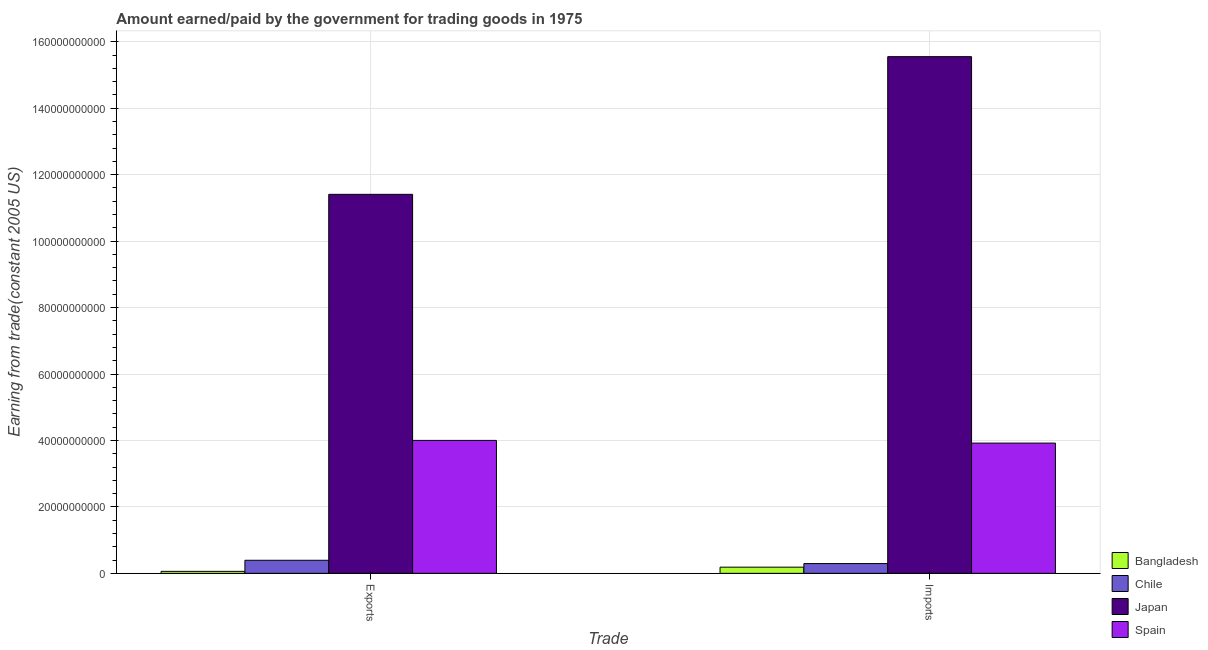How many different coloured bars are there?
Offer a very short reply. 4. How many groups of bars are there?
Provide a succinct answer. 2. Are the number of bars on each tick of the X-axis equal?
Offer a terse response. Yes. What is the label of the 2nd group of bars from the left?
Your answer should be very brief. Imports. What is the amount earned from exports in Spain?
Offer a very short reply. 4.00e+1. Across all countries, what is the maximum amount paid for imports?
Offer a very short reply. 1.56e+11. Across all countries, what is the minimum amount paid for imports?
Your answer should be compact. 1.86e+09. In which country was the amount paid for imports minimum?
Provide a short and direct response. Bangladesh. What is the total amount earned from exports in the graph?
Your answer should be compact. 1.59e+11. What is the difference between the amount paid for imports in Japan and that in Bangladesh?
Keep it short and to the point. 1.54e+11. What is the difference between the amount earned from exports in Bangladesh and the amount paid for imports in Spain?
Give a very brief answer. -3.86e+1. What is the average amount earned from exports per country?
Offer a very short reply. 3.97e+1. What is the difference between the amount paid for imports and amount earned from exports in Chile?
Provide a short and direct response. -9.94e+08. What is the ratio of the amount earned from exports in Spain to that in Chile?
Keep it short and to the point. 10.18. Is the amount earned from exports in Chile less than that in Japan?
Your answer should be compact. Yes. How many bars are there?
Your answer should be compact. 8. Are all the bars in the graph horizontal?
Your answer should be compact. No. What is the difference between two consecutive major ticks on the Y-axis?
Your answer should be compact. 2.00e+1. Are the values on the major ticks of Y-axis written in scientific E-notation?
Your answer should be very brief. No. Does the graph contain any zero values?
Your answer should be compact. No. What is the title of the graph?
Your answer should be very brief. Amount earned/paid by the government for trading goods in 1975. Does "Greenland" appear as one of the legend labels in the graph?
Your answer should be compact. No. What is the label or title of the X-axis?
Provide a succinct answer. Trade. What is the label or title of the Y-axis?
Your answer should be compact. Earning from trade(constant 2005 US). What is the Earning from trade(constant 2005 US) in Bangladesh in Exports?
Give a very brief answer. 5.97e+08. What is the Earning from trade(constant 2005 US) in Chile in Exports?
Keep it short and to the point. 3.93e+09. What is the Earning from trade(constant 2005 US) in Japan in Exports?
Your answer should be very brief. 1.14e+11. What is the Earning from trade(constant 2005 US) in Spain in Exports?
Make the answer very short. 4.00e+1. What is the Earning from trade(constant 2005 US) of Bangladesh in Imports?
Ensure brevity in your answer.  1.86e+09. What is the Earning from trade(constant 2005 US) of Chile in Imports?
Provide a succinct answer. 2.94e+09. What is the Earning from trade(constant 2005 US) of Japan in Imports?
Provide a short and direct response. 1.56e+11. What is the Earning from trade(constant 2005 US) in Spain in Imports?
Your answer should be compact. 3.92e+1. Across all Trade, what is the maximum Earning from trade(constant 2005 US) of Bangladesh?
Keep it short and to the point. 1.86e+09. Across all Trade, what is the maximum Earning from trade(constant 2005 US) of Chile?
Ensure brevity in your answer.  3.93e+09. Across all Trade, what is the maximum Earning from trade(constant 2005 US) in Japan?
Your answer should be very brief. 1.56e+11. Across all Trade, what is the maximum Earning from trade(constant 2005 US) of Spain?
Provide a short and direct response. 4.00e+1. Across all Trade, what is the minimum Earning from trade(constant 2005 US) in Bangladesh?
Your answer should be compact. 5.97e+08. Across all Trade, what is the minimum Earning from trade(constant 2005 US) of Chile?
Provide a short and direct response. 2.94e+09. Across all Trade, what is the minimum Earning from trade(constant 2005 US) of Japan?
Offer a terse response. 1.14e+11. Across all Trade, what is the minimum Earning from trade(constant 2005 US) in Spain?
Make the answer very short. 3.92e+1. What is the total Earning from trade(constant 2005 US) of Bangladesh in the graph?
Keep it short and to the point. 2.45e+09. What is the total Earning from trade(constant 2005 US) in Chile in the graph?
Give a very brief answer. 6.87e+09. What is the total Earning from trade(constant 2005 US) of Japan in the graph?
Provide a succinct answer. 2.70e+11. What is the total Earning from trade(constant 2005 US) in Spain in the graph?
Your response must be concise. 7.92e+1. What is the difference between the Earning from trade(constant 2005 US) of Bangladesh in Exports and that in Imports?
Ensure brevity in your answer.  -1.26e+09. What is the difference between the Earning from trade(constant 2005 US) in Chile in Exports and that in Imports?
Give a very brief answer. 9.94e+08. What is the difference between the Earning from trade(constant 2005 US) of Japan in Exports and that in Imports?
Offer a very short reply. -4.14e+1. What is the difference between the Earning from trade(constant 2005 US) of Spain in Exports and that in Imports?
Provide a succinct answer. 8.10e+08. What is the difference between the Earning from trade(constant 2005 US) of Bangladesh in Exports and the Earning from trade(constant 2005 US) of Chile in Imports?
Offer a terse response. -2.34e+09. What is the difference between the Earning from trade(constant 2005 US) of Bangladesh in Exports and the Earning from trade(constant 2005 US) of Japan in Imports?
Make the answer very short. -1.55e+11. What is the difference between the Earning from trade(constant 2005 US) in Bangladesh in Exports and the Earning from trade(constant 2005 US) in Spain in Imports?
Provide a short and direct response. -3.86e+1. What is the difference between the Earning from trade(constant 2005 US) of Chile in Exports and the Earning from trade(constant 2005 US) of Japan in Imports?
Give a very brief answer. -1.52e+11. What is the difference between the Earning from trade(constant 2005 US) of Chile in Exports and the Earning from trade(constant 2005 US) of Spain in Imports?
Provide a short and direct response. -3.53e+1. What is the difference between the Earning from trade(constant 2005 US) of Japan in Exports and the Earning from trade(constant 2005 US) of Spain in Imports?
Keep it short and to the point. 7.49e+1. What is the average Earning from trade(constant 2005 US) in Bangladesh per Trade?
Your answer should be very brief. 1.23e+09. What is the average Earning from trade(constant 2005 US) of Chile per Trade?
Your response must be concise. 3.44e+09. What is the average Earning from trade(constant 2005 US) in Japan per Trade?
Your answer should be very brief. 1.35e+11. What is the average Earning from trade(constant 2005 US) in Spain per Trade?
Offer a terse response. 3.96e+1. What is the difference between the Earning from trade(constant 2005 US) in Bangladesh and Earning from trade(constant 2005 US) in Chile in Exports?
Provide a succinct answer. -3.34e+09. What is the difference between the Earning from trade(constant 2005 US) in Bangladesh and Earning from trade(constant 2005 US) in Japan in Exports?
Offer a terse response. -1.13e+11. What is the difference between the Earning from trade(constant 2005 US) of Bangladesh and Earning from trade(constant 2005 US) of Spain in Exports?
Offer a very short reply. -3.94e+1. What is the difference between the Earning from trade(constant 2005 US) of Chile and Earning from trade(constant 2005 US) of Japan in Exports?
Provide a short and direct response. -1.10e+11. What is the difference between the Earning from trade(constant 2005 US) in Chile and Earning from trade(constant 2005 US) in Spain in Exports?
Make the answer very short. -3.61e+1. What is the difference between the Earning from trade(constant 2005 US) in Japan and Earning from trade(constant 2005 US) in Spain in Exports?
Offer a terse response. 7.41e+1. What is the difference between the Earning from trade(constant 2005 US) of Bangladesh and Earning from trade(constant 2005 US) of Chile in Imports?
Offer a terse response. -1.08e+09. What is the difference between the Earning from trade(constant 2005 US) in Bangladesh and Earning from trade(constant 2005 US) in Japan in Imports?
Your answer should be very brief. -1.54e+11. What is the difference between the Earning from trade(constant 2005 US) in Bangladesh and Earning from trade(constant 2005 US) in Spain in Imports?
Your answer should be compact. -3.73e+1. What is the difference between the Earning from trade(constant 2005 US) in Chile and Earning from trade(constant 2005 US) in Japan in Imports?
Your response must be concise. -1.53e+11. What is the difference between the Earning from trade(constant 2005 US) of Chile and Earning from trade(constant 2005 US) of Spain in Imports?
Your answer should be very brief. -3.63e+1. What is the difference between the Earning from trade(constant 2005 US) in Japan and Earning from trade(constant 2005 US) in Spain in Imports?
Your answer should be very brief. 1.16e+11. What is the ratio of the Earning from trade(constant 2005 US) in Bangladesh in Exports to that in Imports?
Your response must be concise. 0.32. What is the ratio of the Earning from trade(constant 2005 US) in Chile in Exports to that in Imports?
Give a very brief answer. 1.34. What is the ratio of the Earning from trade(constant 2005 US) in Japan in Exports to that in Imports?
Provide a succinct answer. 0.73. What is the ratio of the Earning from trade(constant 2005 US) of Spain in Exports to that in Imports?
Ensure brevity in your answer.  1.02. What is the difference between the highest and the second highest Earning from trade(constant 2005 US) in Bangladesh?
Your response must be concise. 1.26e+09. What is the difference between the highest and the second highest Earning from trade(constant 2005 US) of Chile?
Your response must be concise. 9.94e+08. What is the difference between the highest and the second highest Earning from trade(constant 2005 US) in Japan?
Offer a terse response. 4.14e+1. What is the difference between the highest and the second highest Earning from trade(constant 2005 US) in Spain?
Your answer should be compact. 8.10e+08. What is the difference between the highest and the lowest Earning from trade(constant 2005 US) of Bangladesh?
Give a very brief answer. 1.26e+09. What is the difference between the highest and the lowest Earning from trade(constant 2005 US) in Chile?
Ensure brevity in your answer.  9.94e+08. What is the difference between the highest and the lowest Earning from trade(constant 2005 US) in Japan?
Your answer should be compact. 4.14e+1. What is the difference between the highest and the lowest Earning from trade(constant 2005 US) of Spain?
Give a very brief answer. 8.10e+08. 